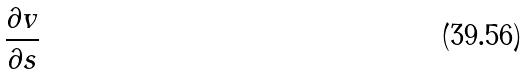Convert formula to latex. <formula><loc_0><loc_0><loc_500><loc_500>\frac { \partial v } { \partial s }</formula> 